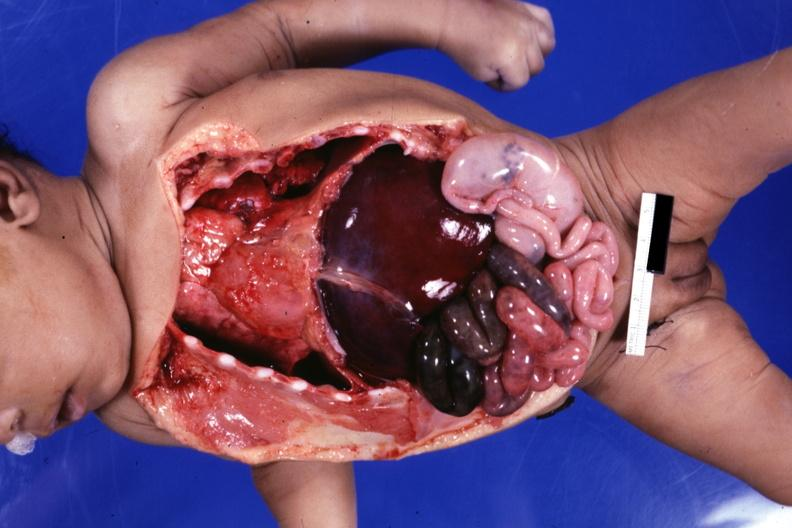what is infant body opened?
Answer the question using a single word or phrase. Showing cardiac apex to right 